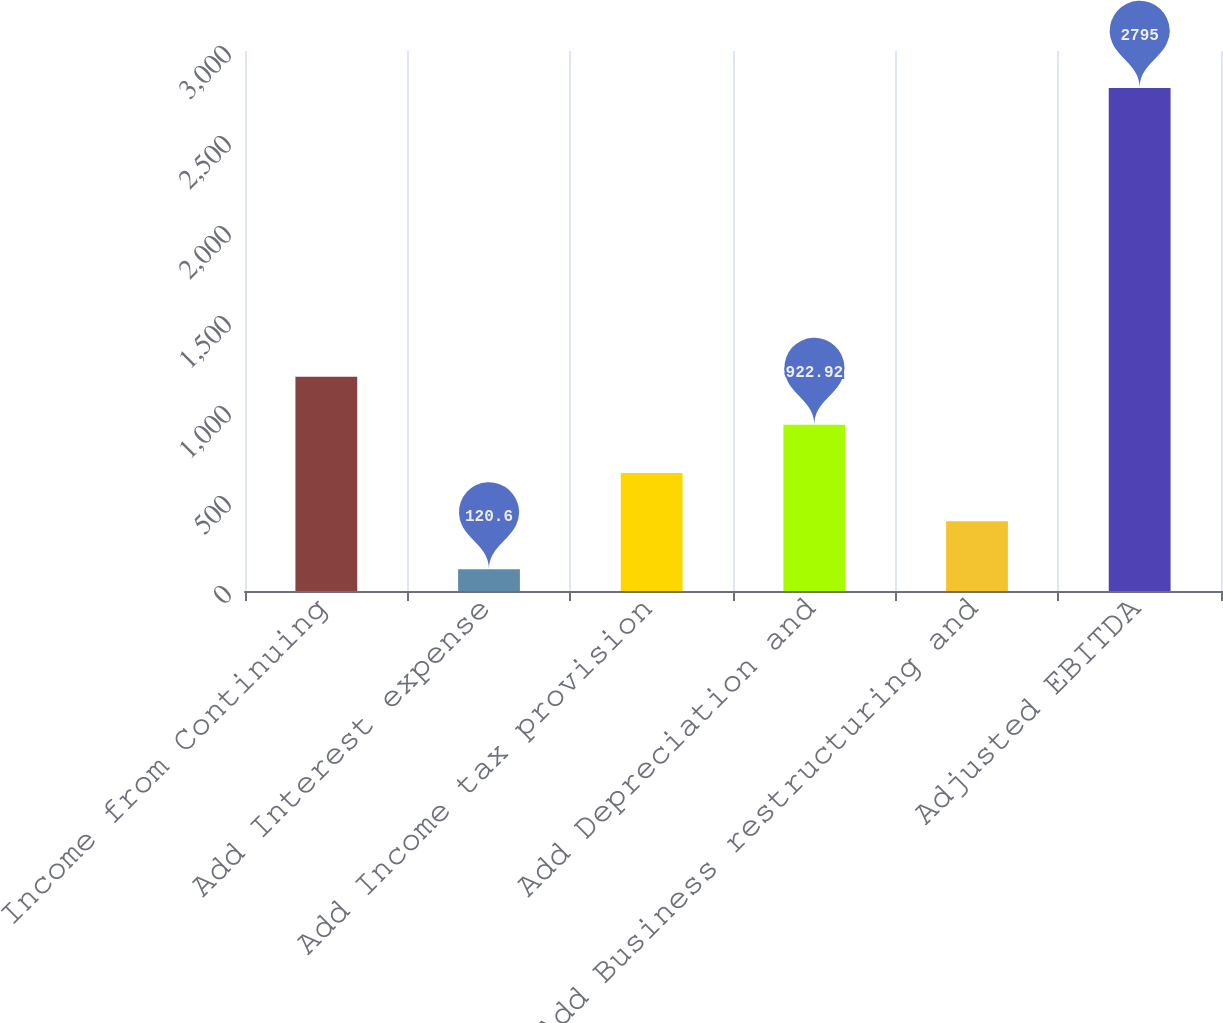Convert chart. <chart><loc_0><loc_0><loc_500><loc_500><bar_chart><fcel>Income from Continuing<fcel>Add Interest expense<fcel>Add Income tax provision<fcel>Add Depreciation and<fcel>Add Business restructuring and<fcel>Adjusted EBITDA<nl><fcel>1190.36<fcel>120.6<fcel>655.48<fcel>922.92<fcel>388.04<fcel>2795<nl></chart> 